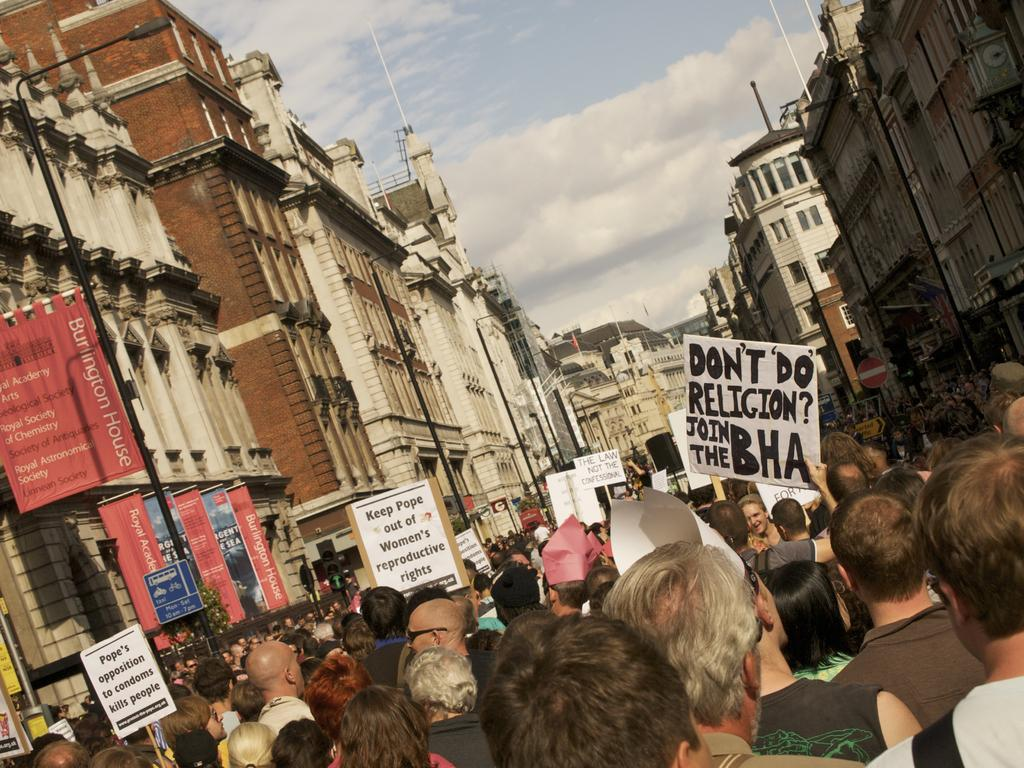How many people are in the image? There is a group of people in the image. What are the people in the image doing? The people are standing and holding placards. What can be seen in the image besides the people? There are poles, lights, and buildings in the background of the image. What is visible in the background of the image? The sky is visible in the background of the image. How many buttons are being distributed by the people in the image? There is no mention of buttons or their distribution in the image. The people are holding placards, not distributing buttons. 